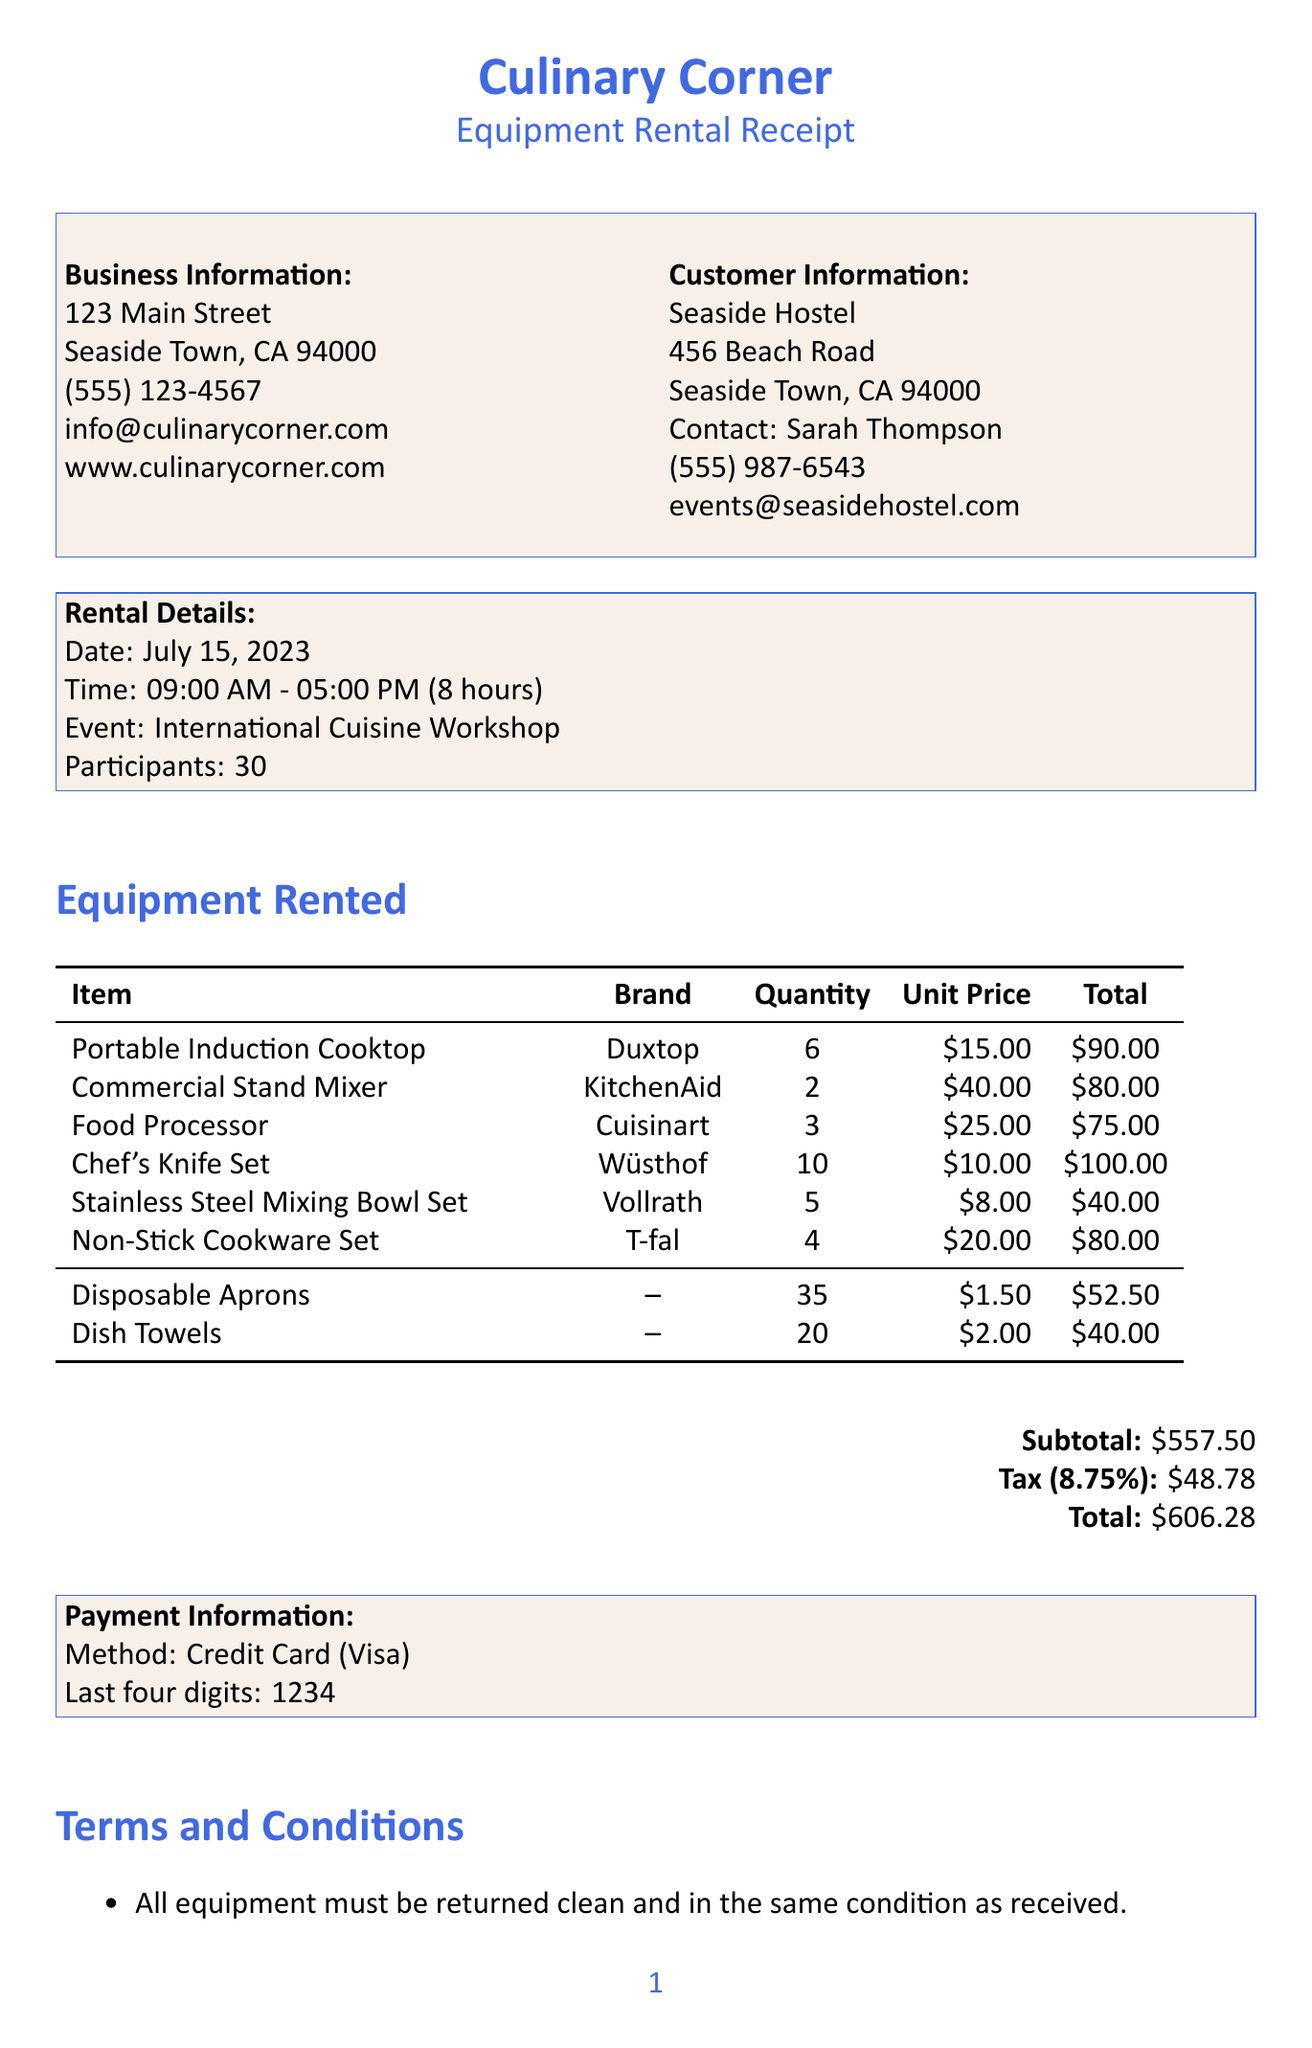what is the name of the business? The document states that the business name is "Culinary Corner."
Answer: Culinary Corner who is the contact person for the customer? The contact person mentioned in the document for the customer is "Sarah Thompson."
Answer: Sarah Thompson how much was charged for the Portable Induction Cooktop? The total price for the Portable Induction Cooktop rented is $90.00.
Answer: $90.00 what is the total amount due? The document lists the total amount due as $606.28.
Answer: $606.28 what is the quantity of Chef's Knife Sets rented? The quantity of Chef's Knife Sets rented is 10.
Answer: 10 how many participants were there in the workshop? The document specifies that there were 30 participants in the workshop.
Answer: 30 what is the security deposit amount required? The document states that a security deposit of $200 is required.
Answer: $200 which item has the highest unit price? The Commercial Stand Mixer has the highest unit price at $40.00.
Answer: Commercial Stand Mixer what is the cancellation policy charge if cancelled within 24 hours? The cancellation policy states that a 50% charge of the total rental fee will apply.
Answer: 50% charge 